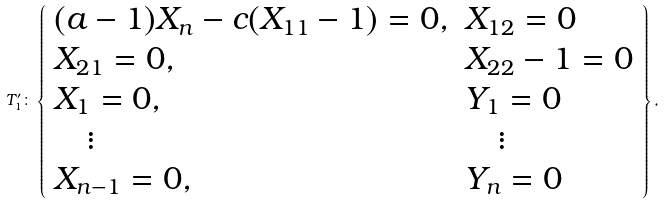Convert formula to latex. <formula><loc_0><loc_0><loc_500><loc_500>T _ { 1 } ^ { \prime } \colon \left \{ \begin{array} { l l } ( a - 1 ) X _ { n } - c ( X _ { 1 1 } - 1 ) = 0 , & X _ { 1 2 } = 0 \\ X _ { 2 1 } = 0 , & X _ { 2 2 } - 1 = 0 \\ X _ { 1 } = 0 , & Y _ { 1 } = 0 \\ \quad \vdots & \quad \vdots \\ X _ { n - 1 } = 0 , & Y _ { n } = 0 \end{array} \right \} ,</formula> 